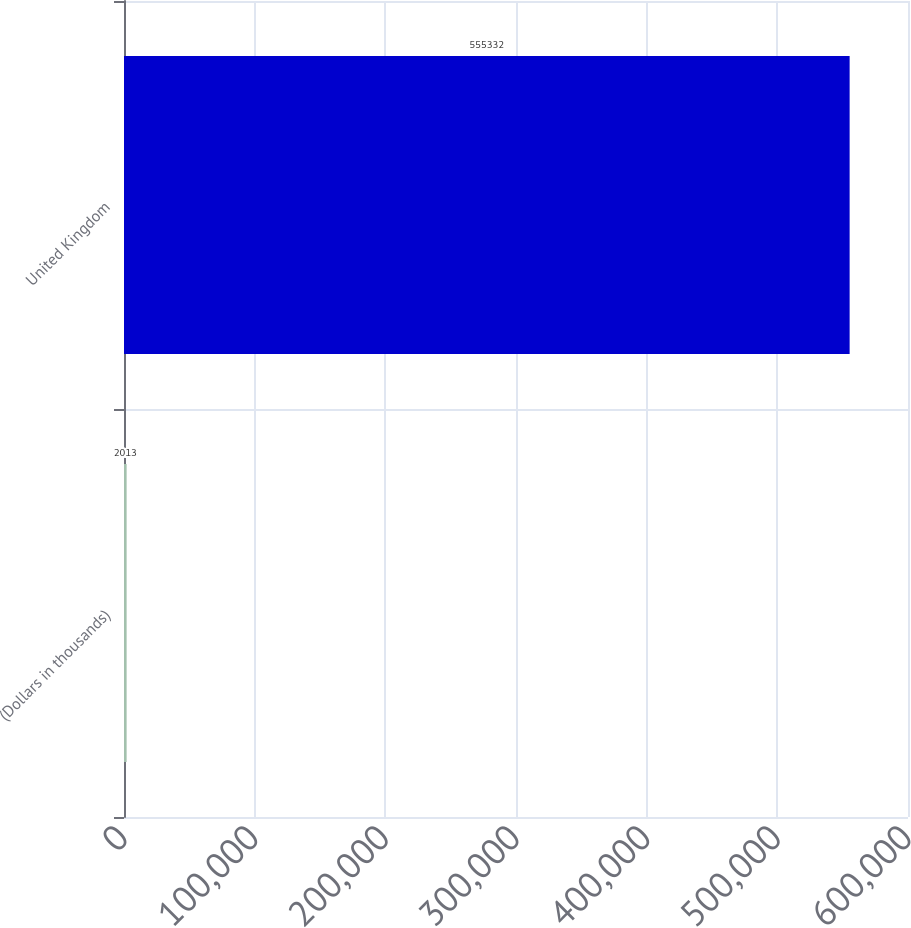Convert chart. <chart><loc_0><loc_0><loc_500><loc_500><bar_chart><fcel>(Dollars in thousands)<fcel>United Kingdom<nl><fcel>2013<fcel>555332<nl></chart> 